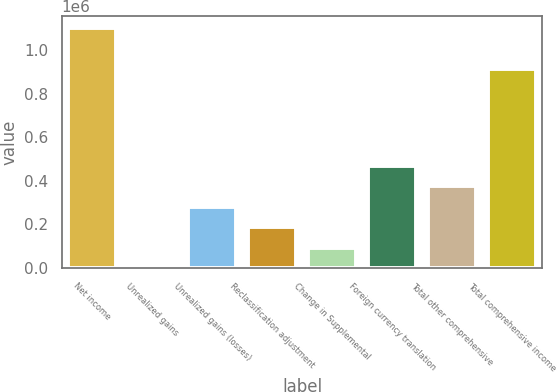<chart> <loc_0><loc_0><loc_500><loc_500><bar_chart><fcel>Net income<fcel>Unrealized gains<fcel>Unrealized gains (losses)<fcel>Reclassification adjustment<fcel>Change in Supplemental<fcel>Foreign currency translation<fcel>Total other comprehensive<fcel>Total comprehensive income<nl><fcel>1.10014e+06<fcel>13<fcel>280986<fcel>187329<fcel>93670.8<fcel>468302<fcel>374644<fcel>912825<nl></chart> 